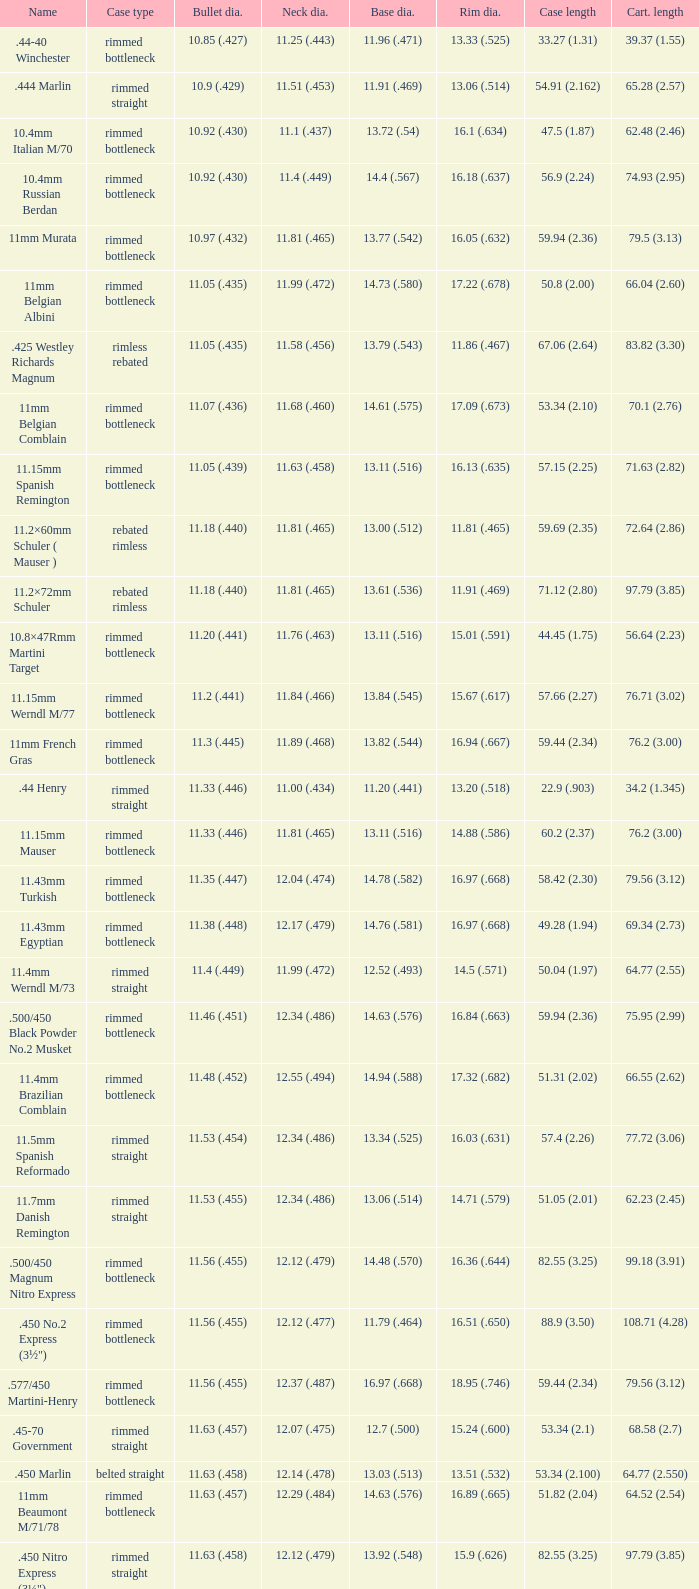Which Case length has a Rim diameter of 13.20 (.518)? 22.9 (.903). 